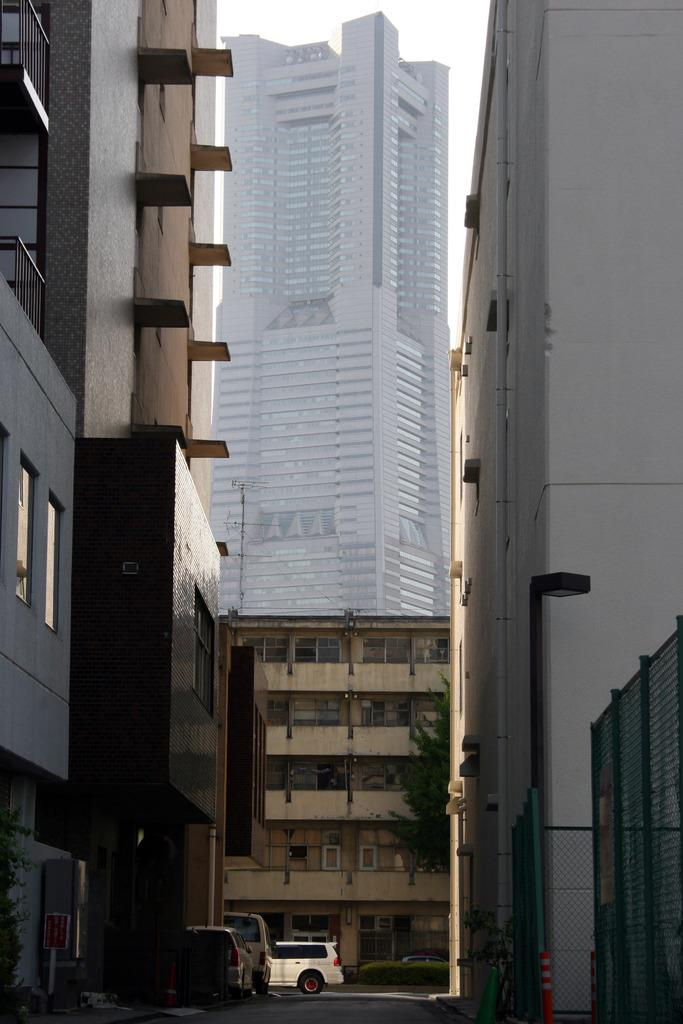What type of structures can be seen in the image? There are buildings in the image. What is the main feature of the image? The main feature of the image is a street. What type of vehicles can be seen on the street? There are cars visible in the image. What is the tendency of the buildings to attack the cars in the image? There is no indication of any attack or aggression between the buildings and cars in the image. The buildings and cars are simply present in the scene. 